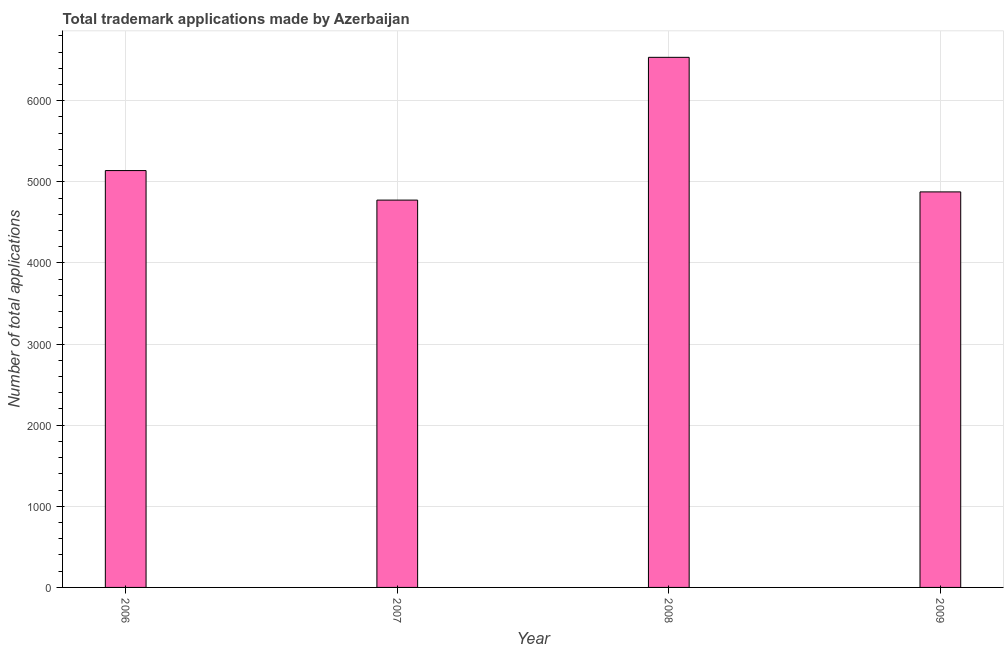Does the graph contain any zero values?
Keep it short and to the point. No. What is the title of the graph?
Your answer should be very brief. Total trademark applications made by Azerbaijan. What is the label or title of the Y-axis?
Make the answer very short. Number of total applications. What is the number of trademark applications in 2006?
Your answer should be very brief. 5139. Across all years, what is the maximum number of trademark applications?
Provide a short and direct response. 6535. Across all years, what is the minimum number of trademark applications?
Provide a succinct answer. 4775. What is the sum of the number of trademark applications?
Offer a terse response. 2.13e+04. What is the difference between the number of trademark applications in 2006 and 2009?
Ensure brevity in your answer.  263. What is the average number of trademark applications per year?
Give a very brief answer. 5331. What is the median number of trademark applications?
Keep it short and to the point. 5007.5. What is the ratio of the number of trademark applications in 2006 to that in 2008?
Give a very brief answer. 0.79. What is the difference between the highest and the second highest number of trademark applications?
Ensure brevity in your answer.  1396. What is the difference between the highest and the lowest number of trademark applications?
Keep it short and to the point. 1760. How many bars are there?
Offer a terse response. 4. Are all the bars in the graph horizontal?
Your answer should be very brief. No. What is the difference between two consecutive major ticks on the Y-axis?
Give a very brief answer. 1000. Are the values on the major ticks of Y-axis written in scientific E-notation?
Your answer should be compact. No. What is the Number of total applications of 2006?
Offer a very short reply. 5139. What is the Number of total applications in 2007?
Keep it short and to the point. 4775. What is the Number of total applications of 2008?
Your answer should be very brief. 6535. What is the Number of total applications in 2009?
Make the answer very short. 4876. What is the difference between the Number of total applications in 2006 and 2007?
Keep it short and to the point. 364. What is the difference between the Number of total applications in 2006 and 2008?
Keep it short and to the point. -1396. What is the difference between the Number of total applications in 2006 and 2009?
Your answer should be compact. 263. What is the difference between the Number of total applications in 2007 and 2008?
Provide a succinct answer. -1760. What is the difference between the Number of total applications in 2007 and 2009?
Your answer should be compact. -101. What is the difference between the Number of total applications in 2008 and 2009?
Give a very brief answer. 1659. What is the ratio of the Number of total applications in 2006 to that in 2007?
Your answer should be compact. 1.08. What is the ratio of the Number of total applications in 2006 to that in 2008?
Provide a succinct answer. 0.79. What is the ratio of the Number of total applications in 2006 to that in 2009?
Ensure brevity in your answer.  1.05. What is the ratio of the Number of total applications in 2007 to that in 2008?
Make the answer very short. 0.73. What is the ratio of the Number of total applications in 2007 to that in 2009?
Offer a terse response. 0.98. What is the ratio of the Number of total applications in 2008 to that in 2009?
Keep it short and to the point. 1.34. 